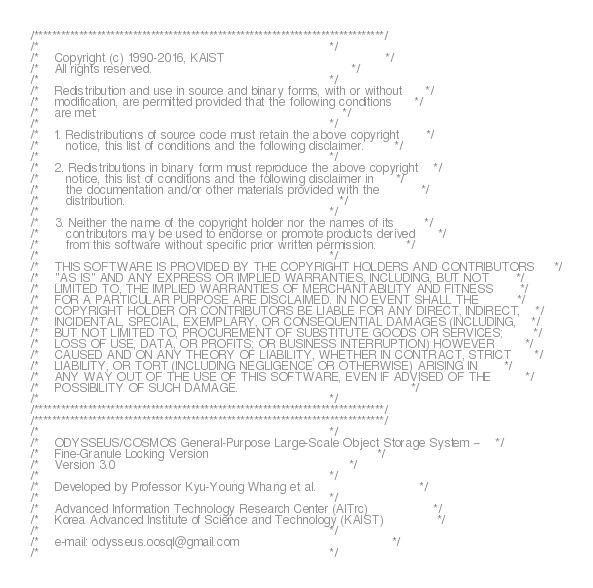<code> <loc_0><loc_0><loc_500><loc_500><_C_>/******************************************************************************/
/*                                                                            */
/*    Copyright (c) 1990-2016, KAIST                                          */
/*    All rights reserved.                                                    */
/*                                                                            */
/*    Redistribution and use in source and binary forms, with or without      */
/*    modification, are permitted provided that the following conditions      */
/*    are met:                                                                */
/*                                                                            */
/*    1. Redistributions of source code must retain the above copyright       */
/*       notice, this list of conditions and the following disclaimer.        */
/*                                                                            */
/*    2. Redistributions in binary form must reproduce the above copyright    */
/*       notice, this list of conditions and the following disclaimer in      */
/*       the documentation and/or other materials provided with the           */
/*       distribution.                                                        */
/*                                                                            */
/*    3. Neither the name of the copyright holder nor the names of its        */
/*       contributors may be used to endorse or promote products derived      */
/*       from this software without specific prior written permission.        */
/*                                                                            */
/*    THIS SOFTWARE IS PROVIDED BY THE COPYRIGHT HOLDERS AND CONTRIBUTORS     */
/*    "AS IS" AND ANY EXPRESS OR IMPLIED WARRANTIES, INCLUDING, BUT NOT       */
/*    LIMITED TO, THE IMPLIED WARRANTIES OF MERCHANTABILITY AND FITNESS       */
/*    FOR A PARTICULAR PURPOSE ARE DISCLAIMED. IN NO EVENT SHALL THE          */
/*    COPYRIGHT HOLDER OR CONTRIBUTORS BE LIABLE FOR ANY DIRECT, INDIRECT,    */
/*    INCIDENTAL, SPECIAL, EXEMPLARY, OR CONSEQUENTIAL DAMAGES (INCLUDING,    */
/*    BUT NOT LIMITED TO, PROCUREMENT OF SUBSTITUTE GOODS OR SERVICES;        */
/*    LOSS OF USE, DATA, OR PROFITS; OR BUSINESS INTERRUPTION) HOWEVER        */
/*    CAUSED AND ON ANY THEORY OF LIABILITY, WHETHER IN CONTRACT, STRICT      */
/*    LIABILITY, OR TORT (INCLUDING NEGLIGENCE OR OTHERWISE) ARISING IN       */
/*    ANY WAY OUT OF THE USE OF THIS SOFTWARE, EVEN IF ADVISED OF THE         */
/*    POSSIBILITY OF SUCH DAMAGE.                                             */
/*                                                                            */
/******************************************************************************/
/******************************************************************************/
/*                                                                            */
/*    ODYSSEUS/COSMOS General-Purpose Large-Scale Object Storage System --    */
/*    Fine-Granule Locking Version                                            */
/*    Version 3.0                                                             */
/*                                                                            */
/*    Developed by Professor Kyu-Young Whang et al.                           */
/*                                                                            */
/*    Advanced Information Technology Research Center (AITrc)                 */
/*    Korea Advanced Institute of Science and Technology (KAIST)              */
/*                                                                            */
/*    e-mail: odysseus.oosql@gmail.com                                        */
/*                                                                            */</code> 